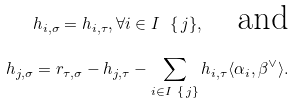<formula> <loc_0><loc_0><loc_500><loc_500>h _ { i , \sigma } = h _ { i , \tau } , \forall i \in I \ \{ \, j \} , \quad \text {and} \\ h _ { j , \sigma } = r _ { \tau , \sigma } - h _ { j , \tau } - \sum _ { i \in I \ \{ \, j \} } h _ { i , \tau } \langle \alpha _ { i } , \beta ^ { \vee } \rangle .</formula> 